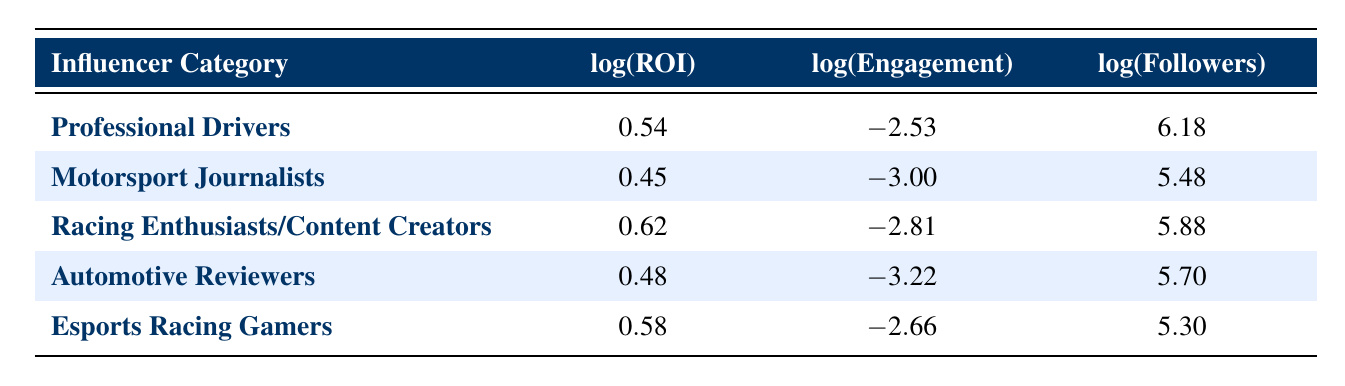What is the log(ROI) for Racing Enthusiasts/Content Creators? The log(ROI) value for Racing Enthusiasts/Content Creators is provided directly in the table.
Answer: 0.62 What is the log(Engagement) of Automotive Reviewers? According to the table, the log(Engagement) of Automotive Reviewers is listed under that specific influencer category.
Answer: -3.22 Which influencer category has the highest log(Followers)? By comparing the log(Followers) values listed in the table, we see that the Professional Drivers category has the highest value of 6.18.
Answer: Professional Drivers What is the difference in log(ROI) between Professional Drivers and Esports Racing Gamers? The log(ROI) for Professional Drivers is 0.54 and for Esports Racing Gamers is 0.58. The difference is calculated as 0.58 - 0.54 = 0.04.
Answer: 0.04 Is the log(Engagement) for Motorsport Journalists greater than -3? The table shows that the log(Engagement) for Motorsport Journalists is -3.00, which is not greater than -3. Therefore, the answer is no.
Answer: No What is the average log(Followers) across all influencer categories? To find the average, first sum all the log(Followers) values: 6.18 + 5.48 + 5.88 + 5.70 + 5.30 = 28.52. Since there are 5 categories, divide by 5: 28.52 / 5 = 5.704.
Answer: 5.704 Which influencer category has the lowest log(Engagement)? By looking at the log(Engagement) values in the table, we see that Automotive Reviewers has the lowest value at -3.22.
Answer: Automotive Reviewers What are the log(ROI) values greater than 0.5? The log(ROI) values greater than 0.5 are for Racing Enthusiasts/Content Creators (0.62) and Esports Racing Gamers (0.58).
Answer: Racing Enthusiasts/Content Creators and Esports Racing Gamers Is it true that Racing Enthusiasts/Content Creators have higher log(ROI) than Motorsport Journalists? The log(ROI) for Racing Enthusiasts/Content Creators is 0.62, while for Motorsport Journalists it is 0.45. Since 0.62 is greater than 0.45, the statement is true.
Answer: Yes 